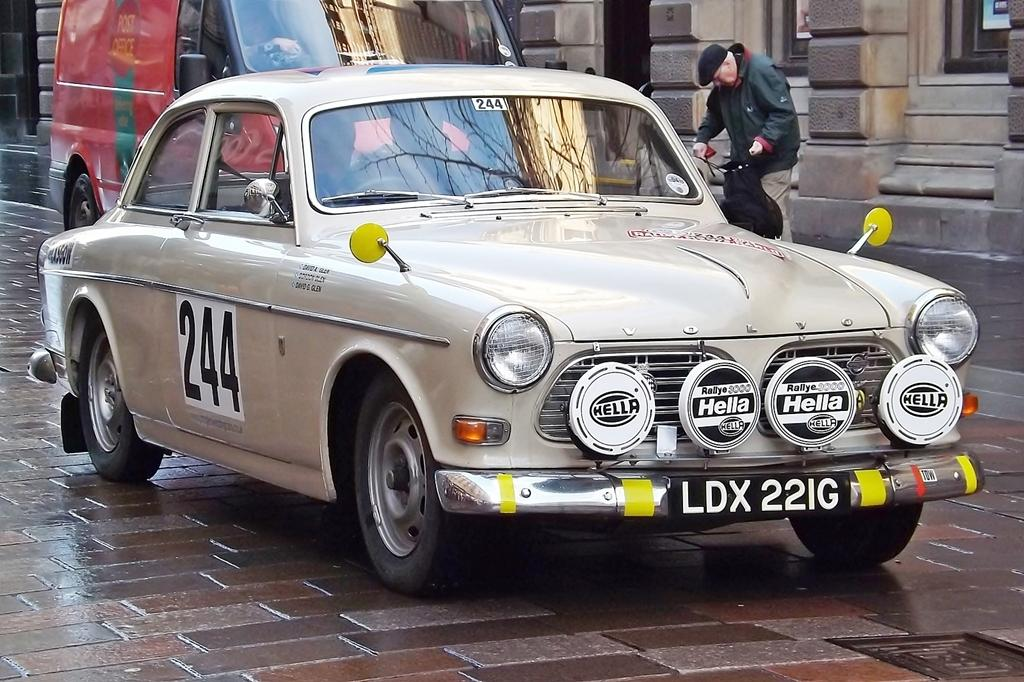What type of vehicle is present in the image? There is a car and a red color van in the image. Can you describe the setting of the image? There is a man standing on a road, and there is a building in the image. How many boats can be seen in the image? There are no boats present in the image. What type of earth is visible in the image? The image does not show any earth or soil; it features a road and a building. 